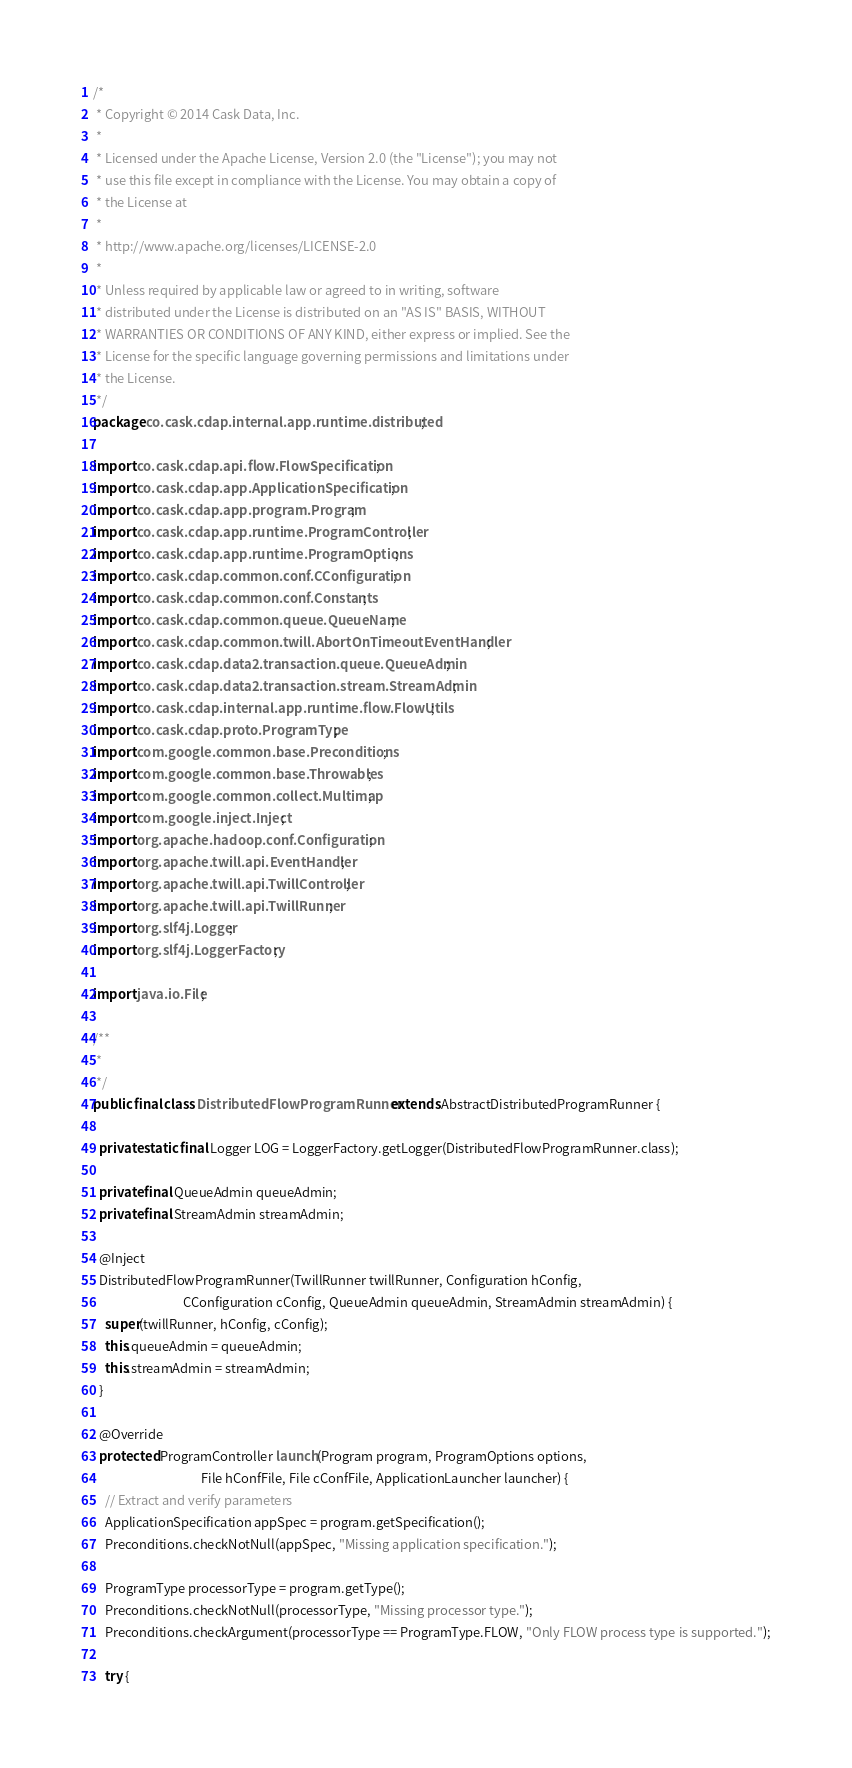Convert code to text. <code><loc_0><loc_0><loc_500><loc_500><_Java_>/*
 * Copyright © 2014 Cask Data, Inc.
 *
 * Licensed under the Apache License, Version 2.0 (the "License"); you may not
 * use this file except in compliance with the License. You may obtain a copy of
 * the License at
 *
 * http://www.apache.org/licenses/LICENSE-2.0
 *
 * Unless required by applicable law or agreed to in writing, software
 * distributed under the License is distributed on an "AS IS" BASIS, WITHOUT
 * WARRANTIES OR CONDITIONS OF ANY KIND, either express or implied. See the
 * License for the specific language governing permissions and limitations under
 * the License.
 */
package co.cask.cdap.internal.app.runtime.distributed;

import co.cask.cdap.api.flow.FlowSpecification;
import co.cask.cdap.app.ApplicationSpecification;
import co.cask.cdap.app.program.Program;
import co.cask.cdap.app.runtime.ProgramController;
import co.cask.cdap.app.runtime.ProgramOptions;
import co.cask.cdap.common.conf.CConfiguration;
import co.cask.cdap.common.conf.Constants;
import co.cask.cdap.common.queue.QueueName;
import co.cask.cdap.common.twill.AbortOnTimeoutEventHandler;
import co.cask.cdap.data2.transaction.queue.QueueAdmin;
import co.cask.cdap.data2.transaction.stream.StreamAdmin;
import co.cask.cdap.internal.app.runtime.flow.FlowUtils;
import co.cask.cdap.proto.ProgramType;
import com.google.common.base.Preconditions;
import com.google.common.base.Throwables;
import com.google.common.collect.Multimap;
import com.google.inject.Inject;
import org.apache.hadoop.conf.Configuration;
import org.apache.twill.api.EventHandler;
import org.apache.twill.api.TwillController;
import org.apache.twill.api.TwillRunner;
import org.slf4j.Logger;
import org.slf4j.LoggerFactory;

import java.io.File;

/**
 *
 */
public final class DistributedFlowProgramRunner extends AbstractDistributedProgramRunner {

  private static final Logger LOG = LoggerFactory.getLogger(DistributedFlowProgramRunner.class);

  private final QueueAdmin queueAdmin;
  private final StreamAdmin streamAdmin;

  @Inject
  DistributedFlowProgramRunner(TwillRunner twillRunner, Configuration hConfig,
                               CConfiguration cConfig, QueueAdmin queueAdmin, StreamAdmin streamAdmin) {
    super(twillRunner, hConfig, cConfig);
    this.queueAdmin = queueAdmin;
    this.streamAdmin = streamAdmin;
  }

  @Override
  protected ProgramController launch(Program program, ProgramOptions options,
                                     File hConfFile, File cConfFile, ApplicationLauncher launcher) {
    // Extract and verify parameters
    ApplicationSpecification appSpec = program.getSpecification();
    Preconditions.checkNotNull(appSpec, "Missing application specification.");

    ProgramType processorType = program.getType();
    Preconditions.checkNotNull(processorType, "Missing processor type.");
    Preconditions.checkArgument(processorType == ProgramType.FLOW, "Only FLOW process type is supported.");

    try {</code> 